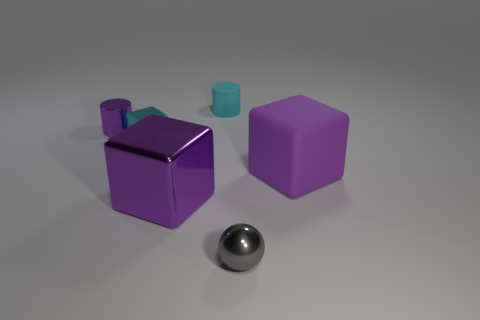Does the large thing that is on the left side of the big rubber thing have the same material as the tiny object in front of the large shiny cube?
Your response must be concise. Yes. What material is the cyan cylinder?
Make the answer very short. Rubber. How many other things are the same color as the ball?
Offer a very short reply. 0. Is the small rubber cylinder the same color as the tiny cube?
Offer a very short reply. Yes. How many large purple metal things are there?
Offer a very short reply. 1. What is the large block behind the purple block that is on the left side of the ball made of?
Give a very brief answer. Rubber. There is a cyan cylinder that is the same size as the ball; what material is it?
Your answer should be very brief. Rubber. Is the size of the purple metallic thing in front of the cyan metal block the same as the cyan metal thing?
Offer a very short reply. No. There is a shiny thing that is to the right of the small cyan cylinder; does it have the same shape as the small cyan metallic object?
Ensure brevity in your answer.  No. What number of objects are balls or cubes that are to the right of the small gray shiny thing?
Make the answer very short. 2. 